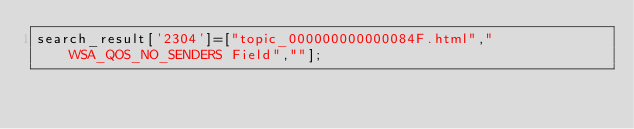<code> <loc_0><loc_0><loc_500><loc_500><_JavaScript_>search_result['2304']=["topic_000000000000084F.html","WSA_QOS_NO_SENDERS Field",""];</code> 